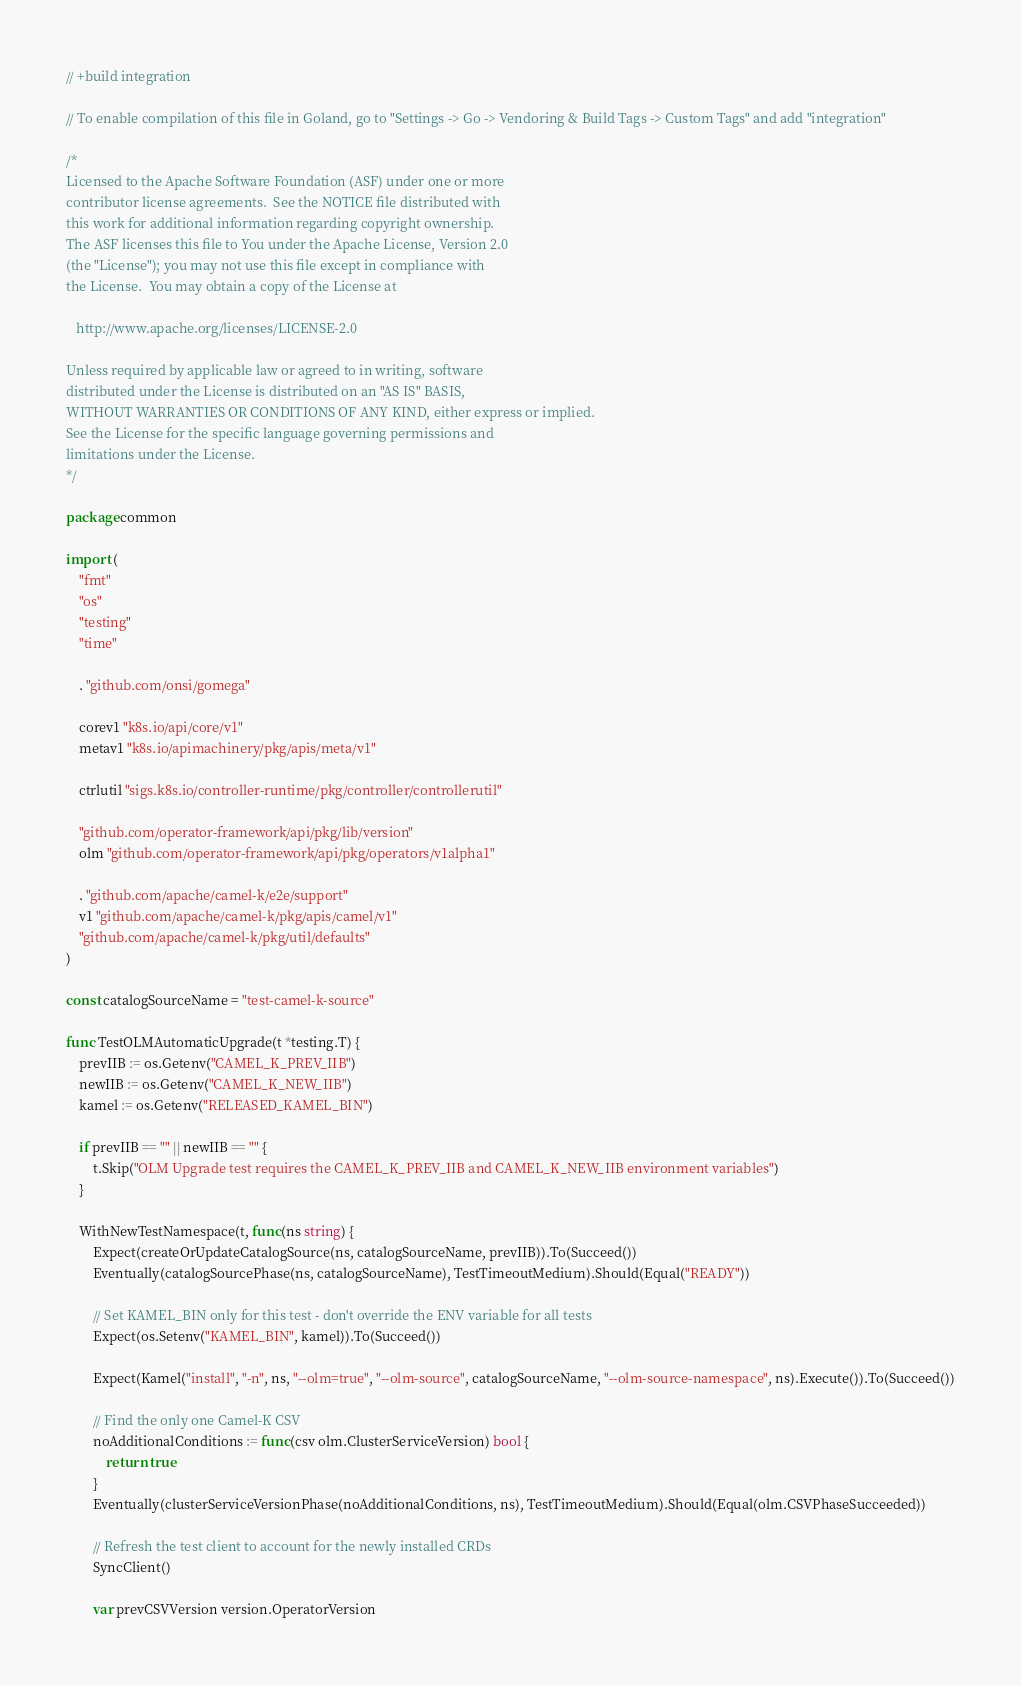<code> <loc_0><loc_0><loc_500><loc_500><_Go_>// +build integration

// To enable compilation of this file in Goland, go to "Settings -> Go -> Vendoring & Build Tags -> Custom Tags" and add "integration"

/*
Licensed to the Apache Software Foundation (ASF) under one or more
contributor license agreements.  See the NOTICE file distributed with
this work for additional information regarding copyright ownership.
The ASF licenses this file to You under the Apache License, Version 2.0
(the "License"); you may not use this file except in compliance with
the License.  You may obtain a copy of the License at

   http://www.apache.org/licenses/LICENSE-2.0

Unless required by applicable law or agreed to in writing, software
distributed under the License is distributed on an "AS IS" BASIS,
WITHOUT WARRANTIES OR CONDITIONS OF ANY KIND, either express or implied.
See the License for the specific language governing permissions and
limitations under the License.
*/

package common

import (
	"fmt"
	"os"
	"testing"
	"time"

	. "github.com/onsi/gomega"

	corev1 "k8s.io/api/core/v1"
	metav1 "k8s.io/apimachinery/pkg/apis/meta/v1"

	ctrlutil "sigs.k8s.io/controller-runtime/pkg/controller/controllerutil"

	"github.com/operator-framework/api/pkg/lib/version"
	olm "github.com/operator-framework/api/pkg/operators/v1alpha1"

	. "github.com/apache/camel-k/e2e/support"
	v1 "github.com/apache/camel-k/pkg/apis/camel/v1"
	"github.com/apache/camel-k/pkg/util/defaults"
)

const catalogSourceName = "test-camel-k-source"

func TestOLMAutomaticUpgrade(t *testing.T) {
	prevIIB := os.Getenv("CAMEL_K_PREV_IIB")
	newIIB := os.Getenv("CAMEL_K_NEW_IIB")
	kamel := os.Getenv("RELEASED_KAMEL_BIN")

	if prevIIB == "" || newIIB == "" {
		t.Skip("OLM Upgrade test requires the CAMEL_K_PREV_IIB and CAMEL_K_NEW_IIB environment variables")
	}

	WithNewTestNamespace(t, func(ns string) {
		Expect(createOrUpdateCatalogSource(ns, catalogSourceName, prevIIB)).To(Succeed())
		Eventually(catalogSourcePhase(ns, catalogSourceName), TestTimeoutMedium).Should(Equal("READY"))

		// Set KAMEL_BIN only for this test - don't override the ENV variable for all tests
		Expect(os.Setenv("KAMEL_BIN", kamel)).To(Succeed())

		Expect(Kamel("install", "-n", ns, "--olm=true", "--olm-source", catalogSourceName, "--olm-source-namespace", ns).Execute()).To(Succeed())

		// Find the only one Camel-K CSV
		noAdditionalConditions := func(csv olm.ClusterServiceVersion) bool {
			return true
		}
		Eventually(clusterServiceVersionPhase(noAdditionalConditions, ns), TestTimeoutMedium).Should(Equal(olm.CSVPhaseSucceeded))

		// Refresh the test client to account for the newly installed CRDs
		SyncClient()

		var prevCSVVersion version.OperatorVersion</code> 